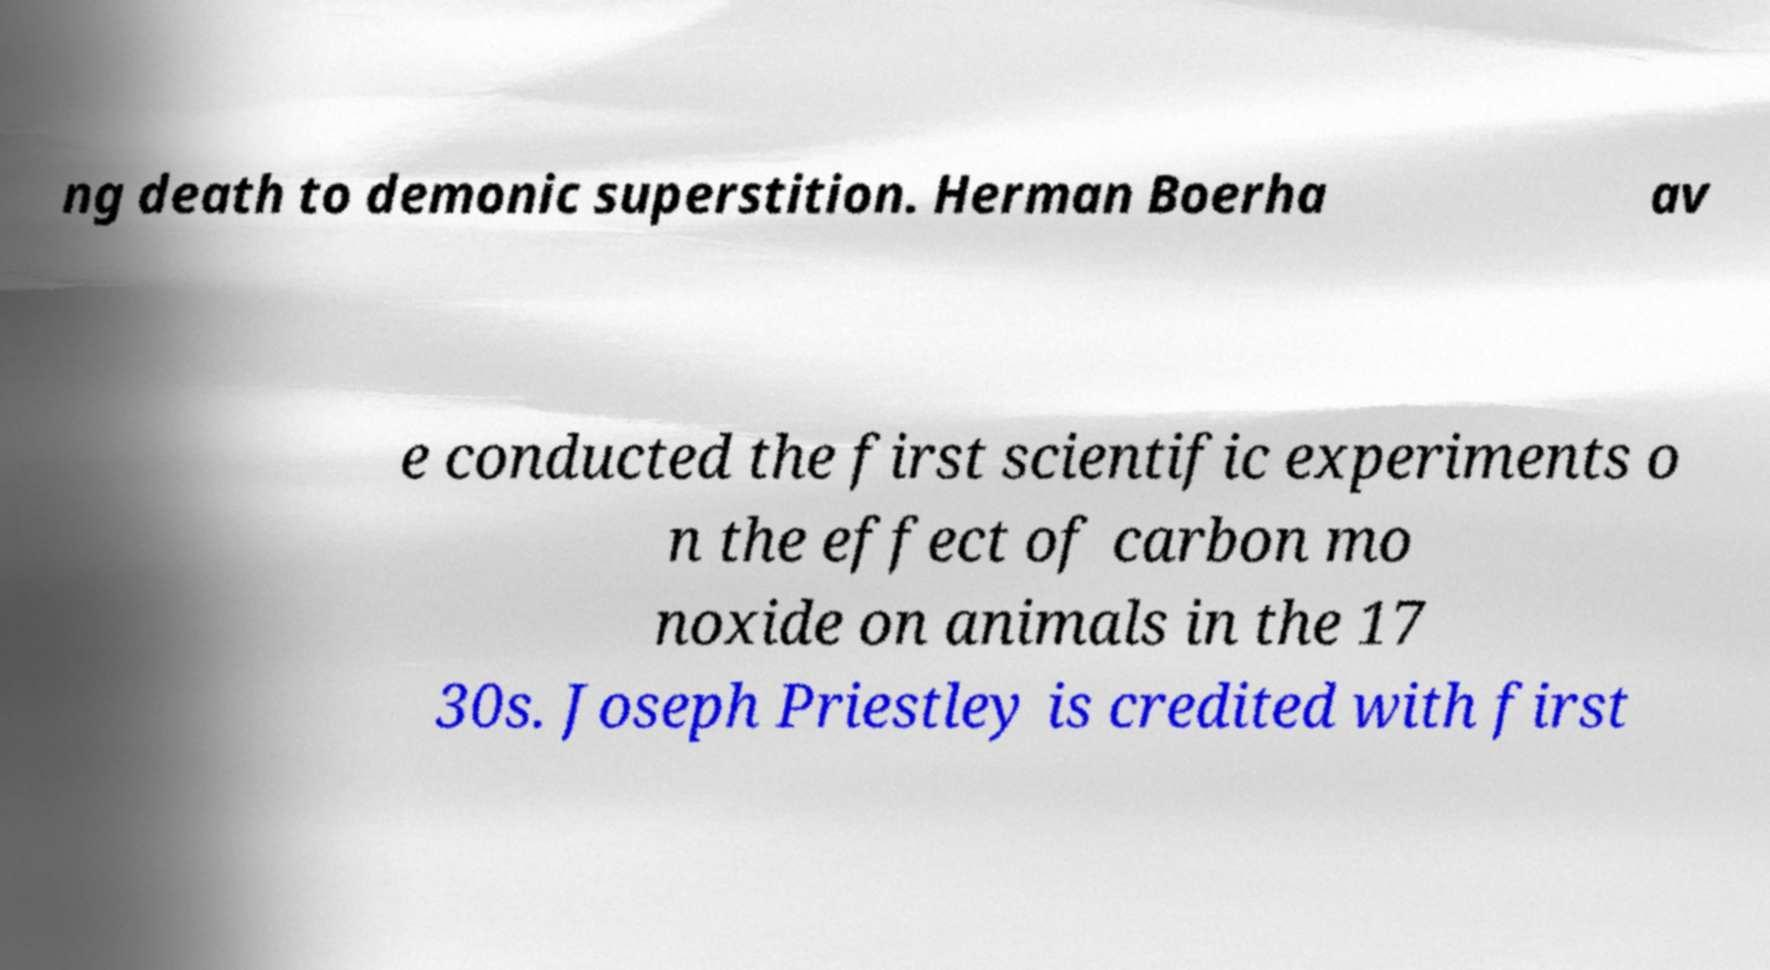For documentation purposes, I need the text within this image transcribed. Could you provide that? ng death to demonic superstition. Herman Boerha av e conducted the first scientific experiments o n the effect of carbon mo noxide on animals in the 17 30s. Joseph Priestley is credited with first 